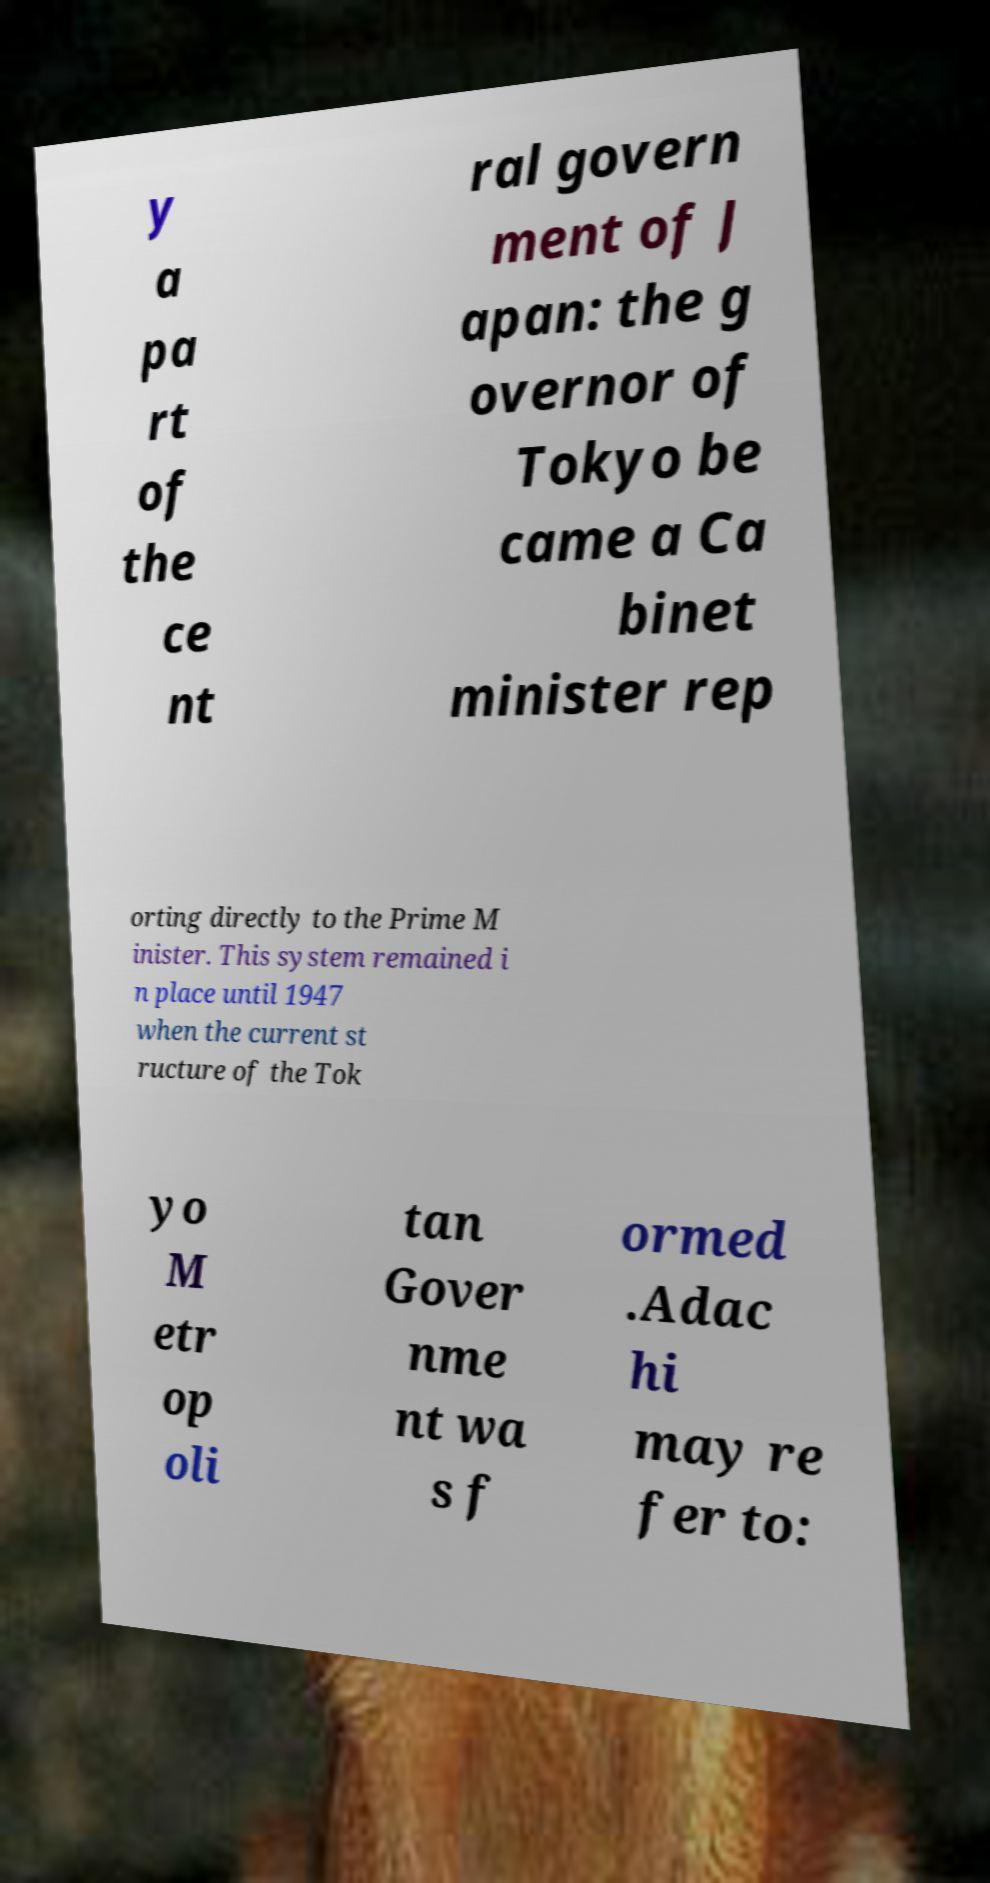I need the written content from this picture converted into text. Can you do that? y a pa rt of the ce nt ral govern ment of J apan: the g overnor of Tokyo be came a Ca binet minister rep orting directly to the Prime M inister. This system remained i n place until 1947 when the current st ructure of the Tok yo M etr op oli tan Gover nme nt wa s f ormed .Adac hi may re fer to: 